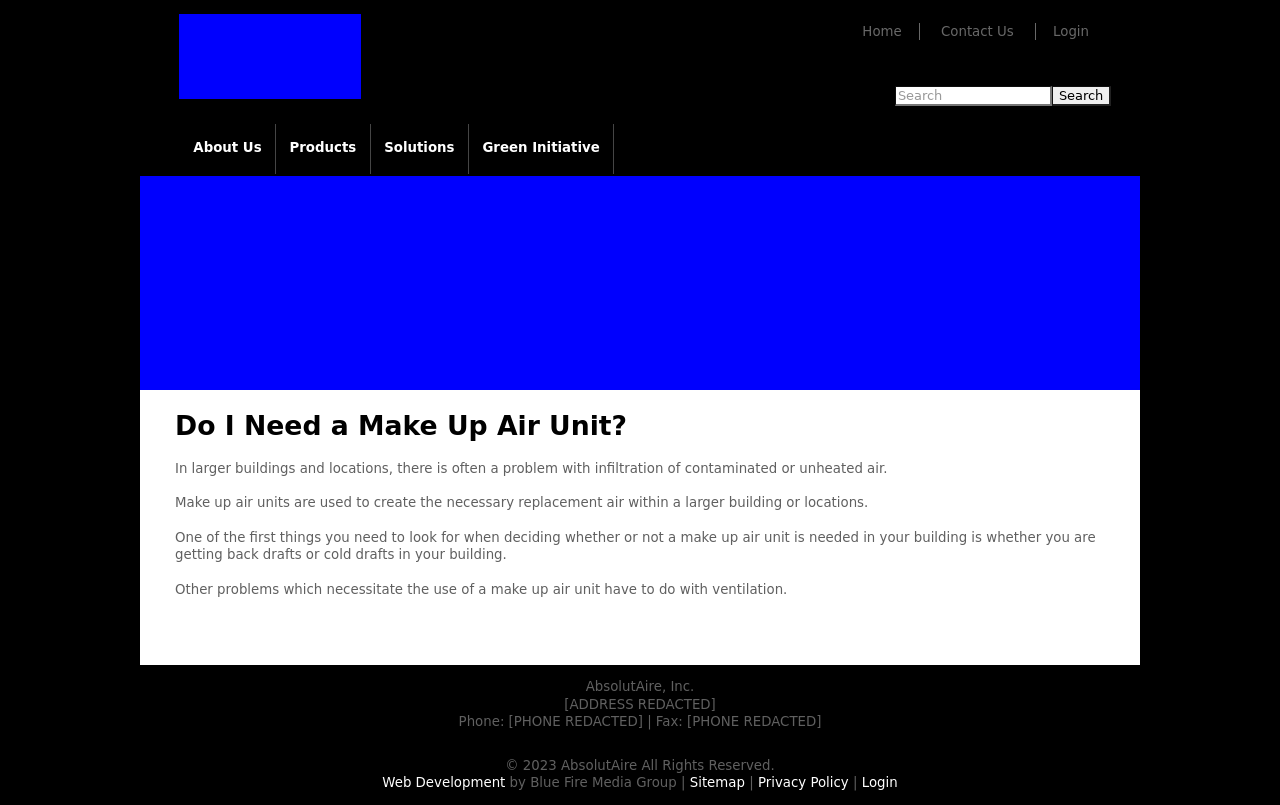What impact does the choice of color scheme have on user experience for this website? The blue color scheme of the website shown contributes to a sense of reliability and professionalism. Blue is often associated with trust, peace, and efficiency, which can positively influence how users perceive the brand. This color can help users feel more secure browsing and interacting with the site, potentially increasing user engagement and satisfaction. 